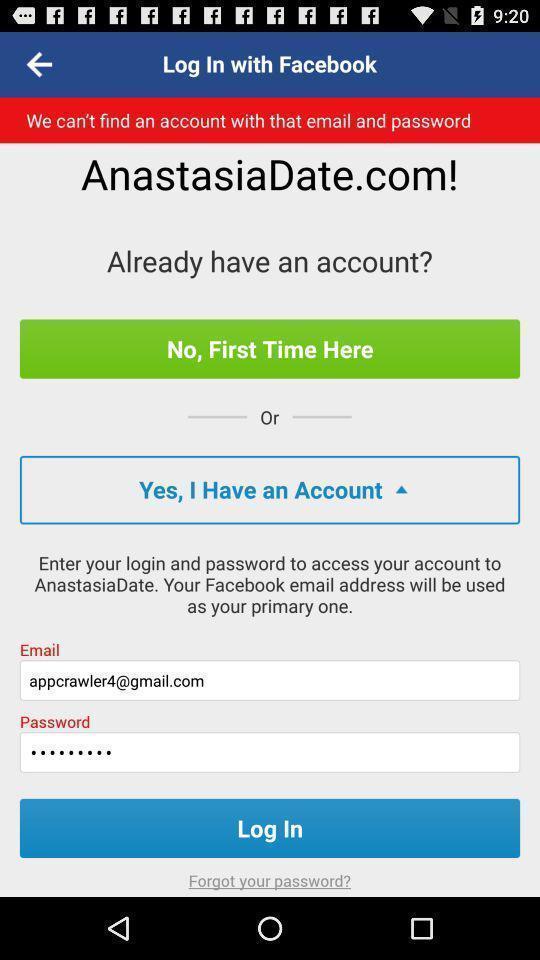Summarize the main components in this picture. Welcome page with login options in a dating app. 